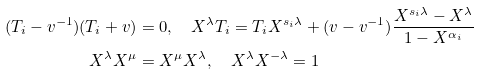<formula> <loc_0><loc_0><loc_500><loc_500>( T _ { i } - v ^ { - 1 } ) ( T _ { i } + v ) & = 0 , \quad X ^ { \lambda } T _ { i } = T _ { i } X ^ { s _ { i } \lambda } + ( v - v ^ { - 1 } ) \frac { X ^ { s _ { i } \lambda } - X ^ { \lambda } } { 1 - X ^ { \alpha _ { i } } } \\ X ^ { \lambda } X ^ { \mu } & = X ^ { \mu } X ^ { \lambda } , \quad X ^ { \lambda } X ^ { - \lambda } = 1</formula> 